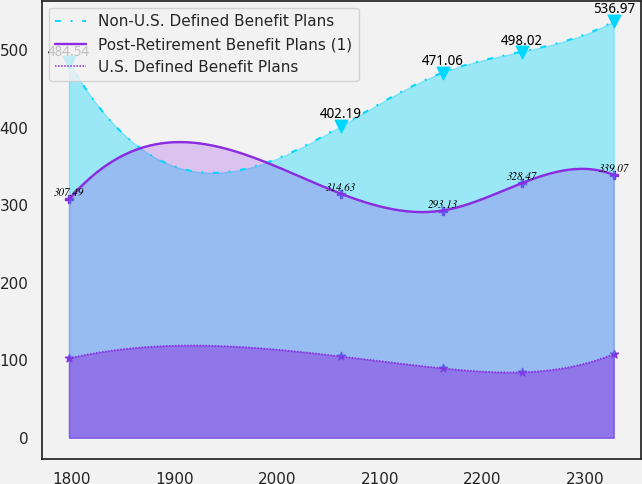Convert chart. <chart><loc_0><loc_0><loc_500><loc_500><line_chart><ecel><fcel>Non-U.S. Defined Benefit Plans<fcel>Post-Retirement Benefit Plans (1)<fcel>U.S. Defined Benefit Plans<nl><fcel>1797.7<fcel>484.54<fcel>307.49<fcel>102.5<nl><fcel>2062.6<fcel>402.19<fcel>314.63<fcel>104.85<nl><fcel>2161.24<fcel>471.06<fcel>293.13<fcel>89.58<nl><fcel>2238.27<fcel>498.02<fcel>328.47<fcel>84.49<nl><fcel>2327.7<fcel>536.97<fcel>339.07<fcel>108<nl></chart> 